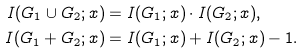Convert formula to latex. <formula><loc_0><loc_0><loc_500><loc_500>I ( G _ { 1 } \cup G _ { 2 } ; x ) & = I ( G _ { 1 } ; x ) \cdot I ( G _ { 2 } ; x ) , \\ I ( G _ { 1 } + G _ { 2 } ; x ) & = I ( G _ { 1 } ; x ) + I ( G _ { 2 } ; x ) - 1 .</formula> 